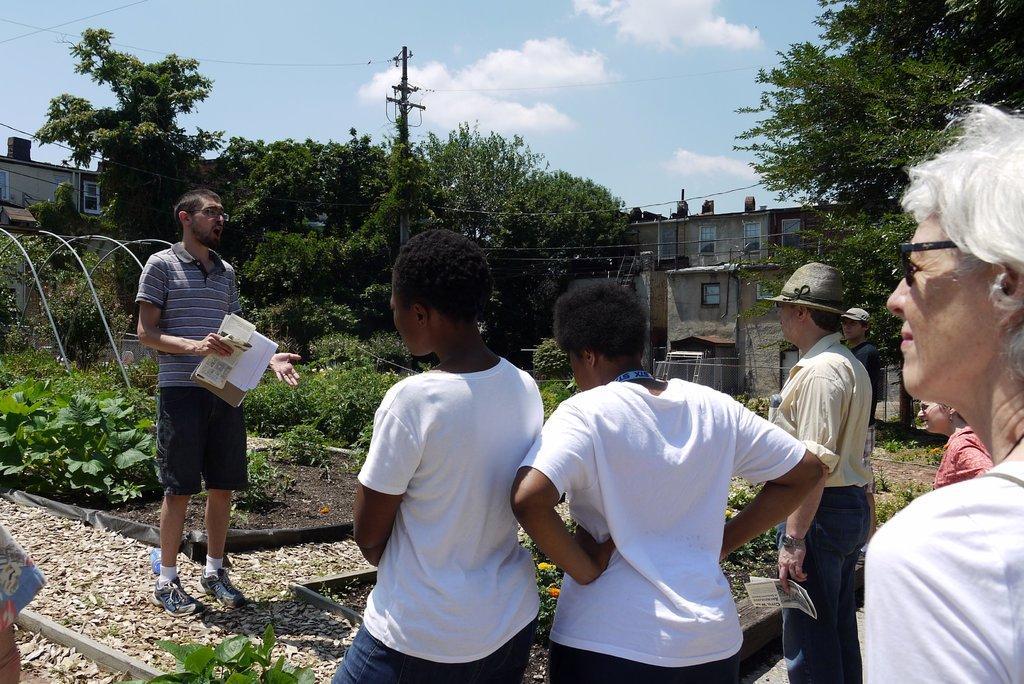Can you describe this image briefly? In this picture we can see a group of people were two men are holding papers with their hands, caps, spectacles, plants, stones, trees, poles, wires, buildings with windows and some objects and in the background we can see the sky with clouds. 